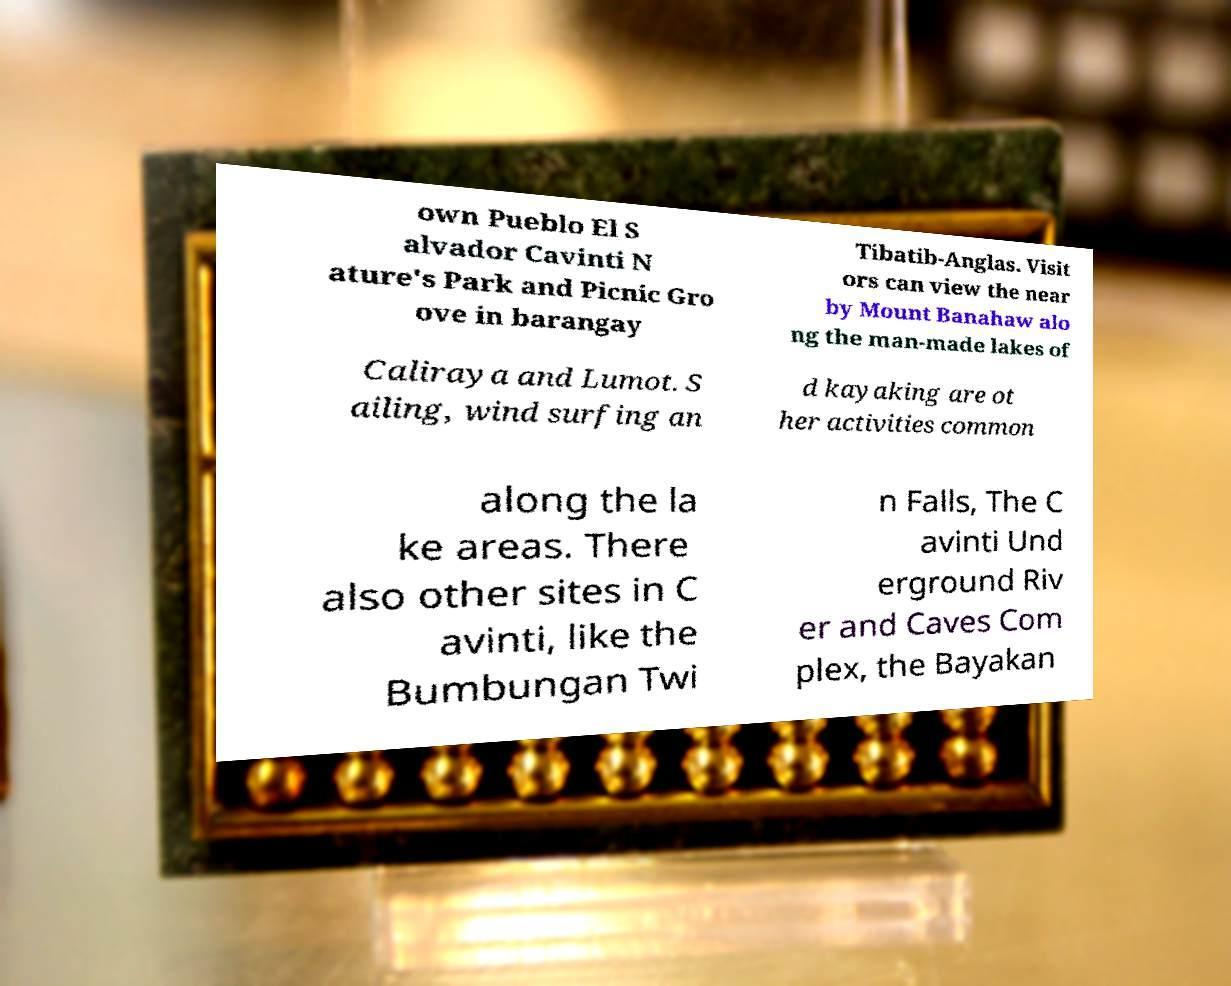I need the written content from this picture converted into text. Can you do that? own Pueblo El S alvador Cavinti N ature's Park and Picnic Gro ove in barangay Tibatib-Anglas. Visit ors can view the near by Mount Banahaw alo ng the man-made lakes of Caliraya and Lumot. S ailing, wind surfing an d kayaking are ot her activities common along the la ke areas. There also other sites in C avinti, like the Bumbungan Twi n Falls, The C avinti Und erground Riv er and Caves Com plex, the Bayakan 